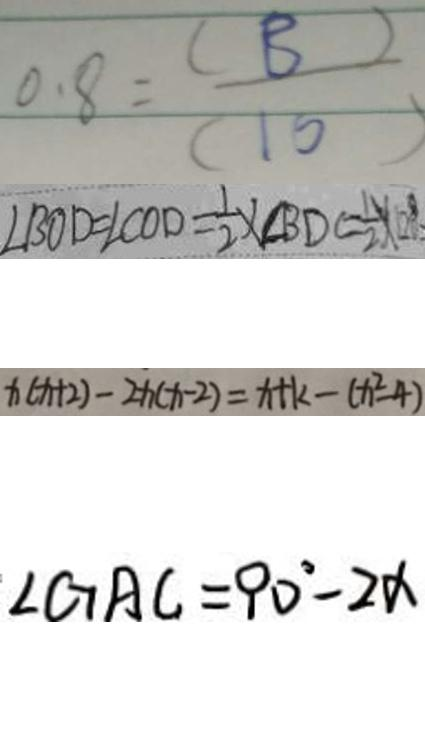<formula> <loc_0><loc_0><loc_500><loc_500>0 . 8 = \frac { ( B ) } { ( 1 0 ) } 
 \angle B O D = \angle C O D = \frac { 1 } { 2 } \times \angle B D C = \frac { 1 } { 2 } \times 1 2 0 ^ { \circ } 
 x ( x + 2 ) - 2 x ( x - 2 ) = x + k - ( x ^ { 2 } - 4 ) 
 \angle G A C = 9 0 ^ { \circ } - 2 \alpha</formula> 